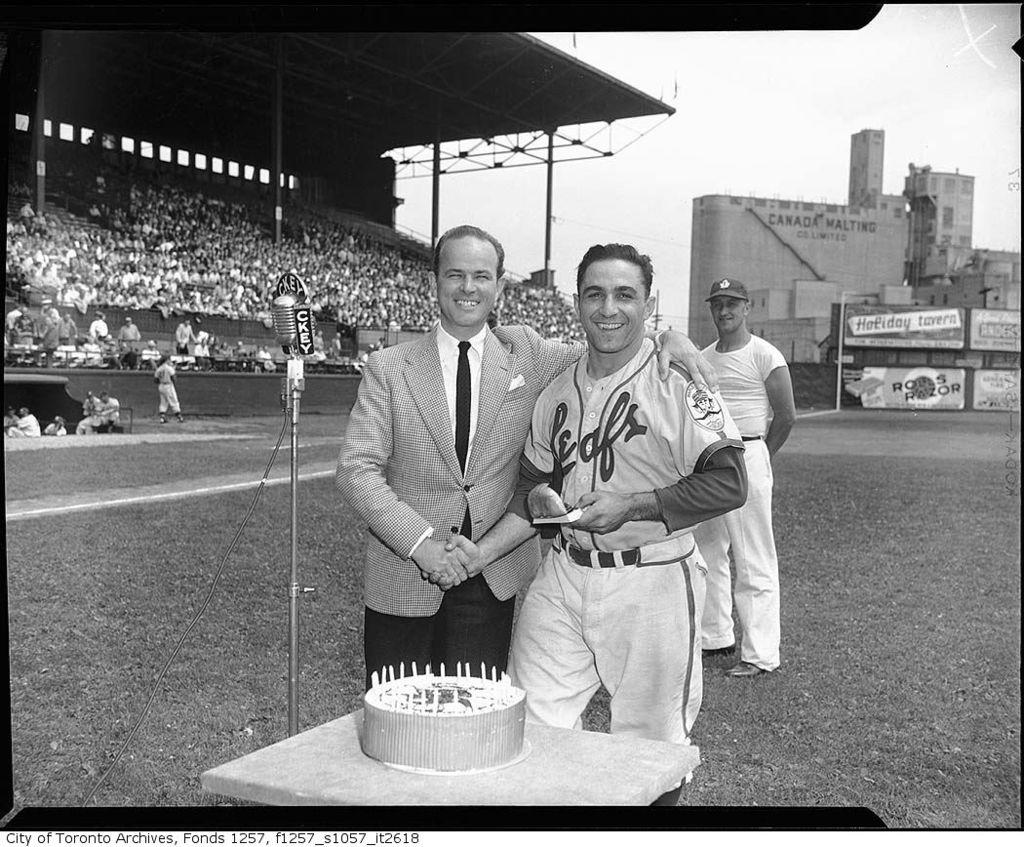What building is in the background?
Offer a very short reply. Canada malting. 